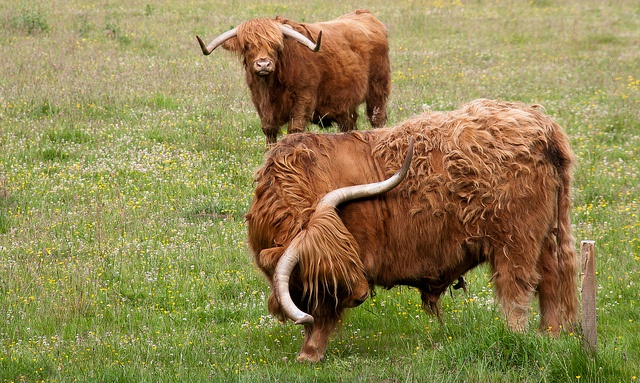Describe the objects in this image and their specific colors. I can see cow in tan, maroon, brown, salmon, and black tones and cow in tan, maroon, brown, and black tones in this image. 